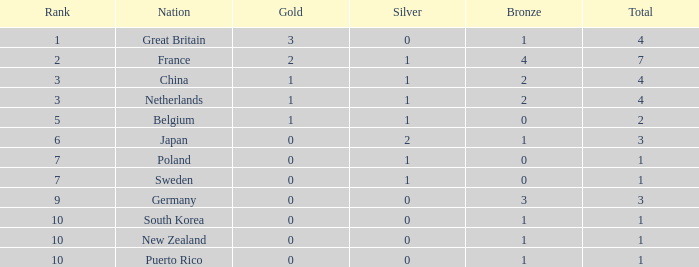What is the sum when the gold amount exceeds 2? 1.0. 